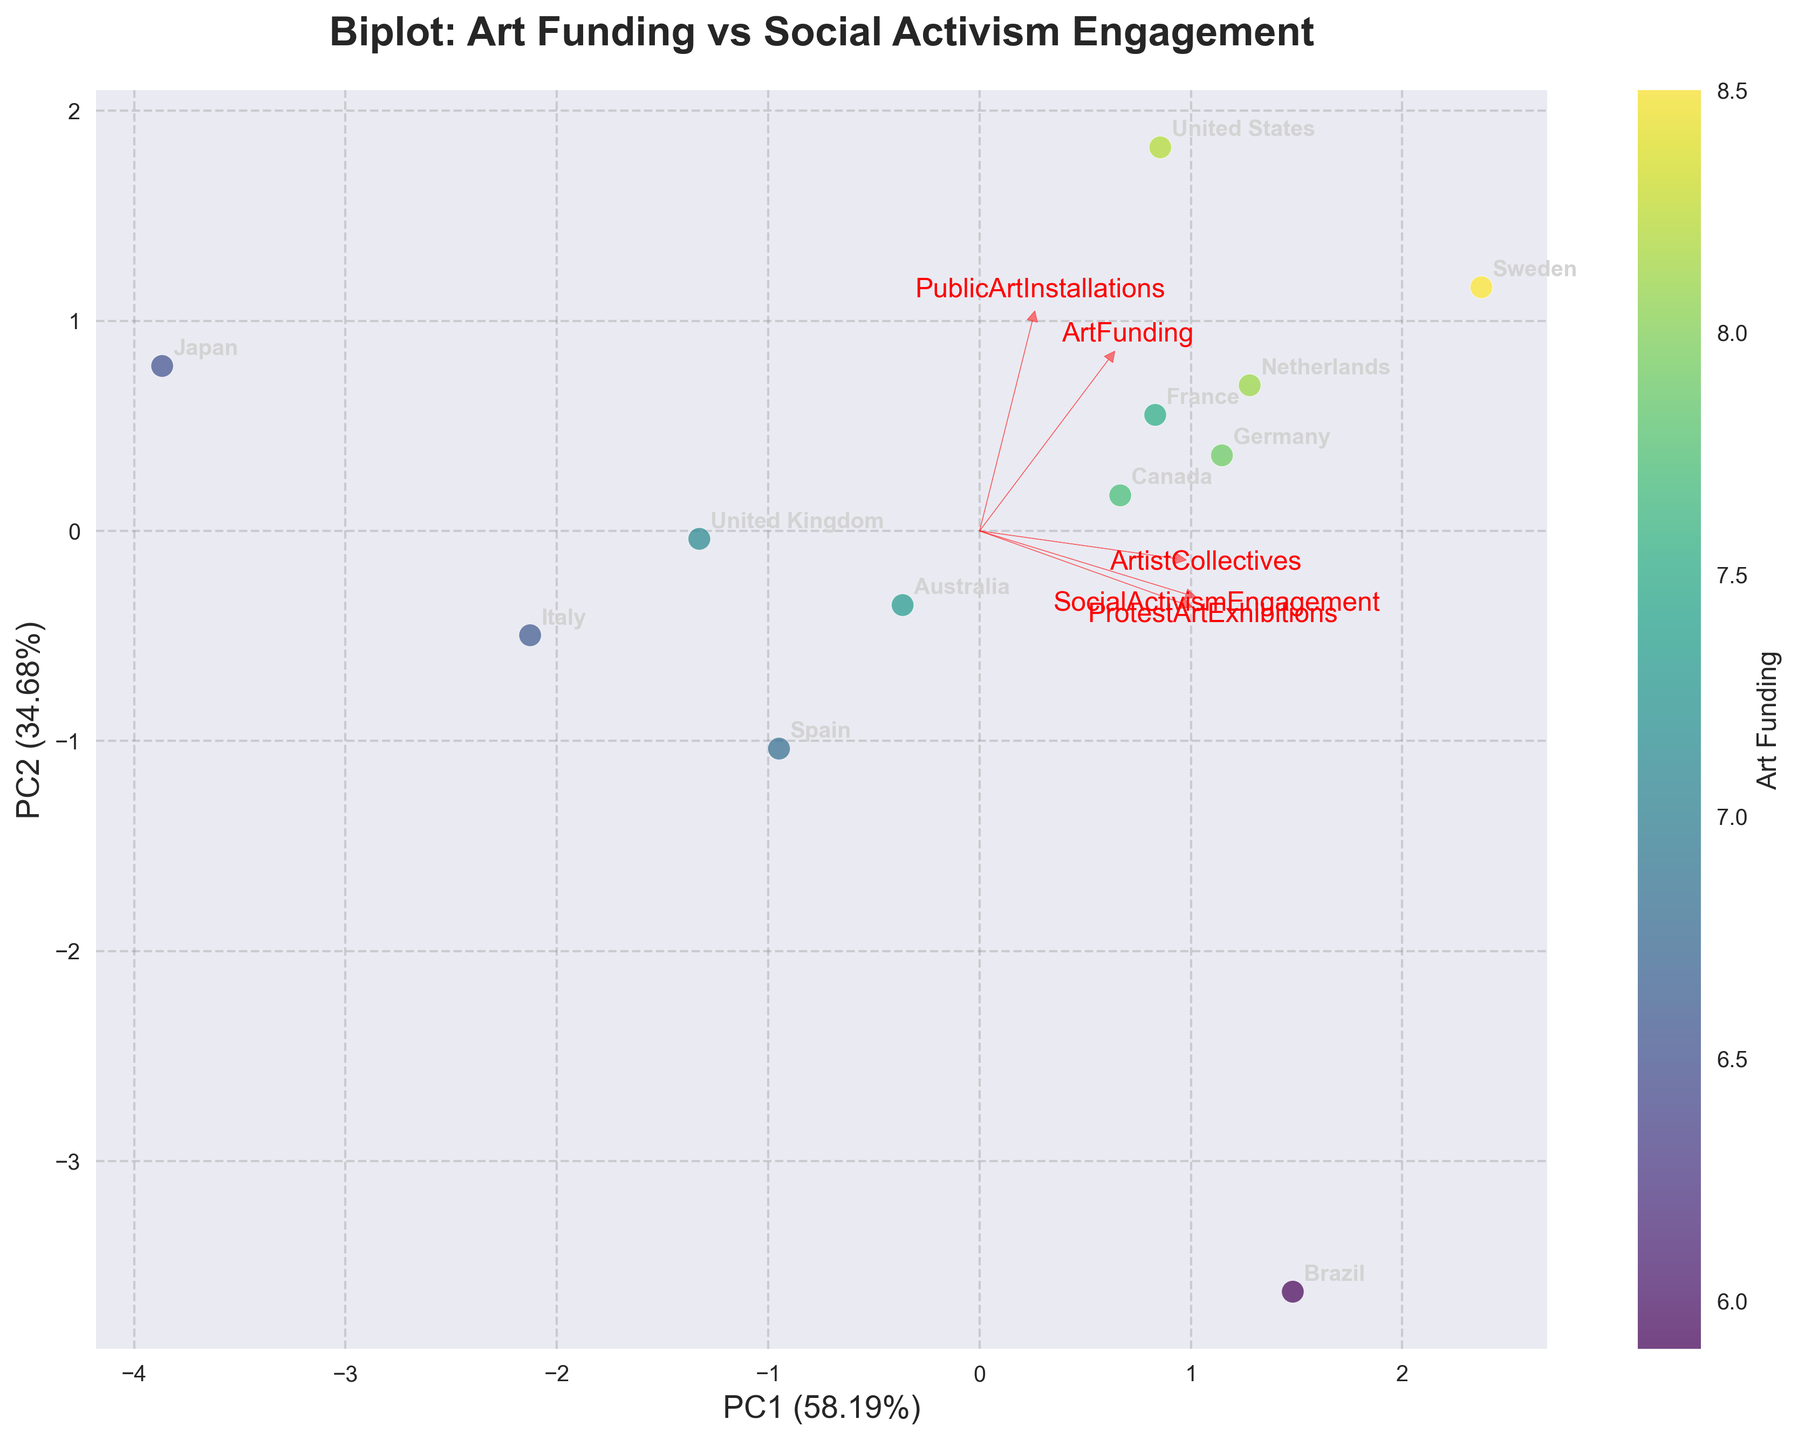What is the title of the figure? The title of the figure is prominently displayed at the top and reads "Biplot: Art Funding vs Social Activism Engagement".
Answer: Biplot: Art Funding vs Social Activism Engagement How many countries are represented in the plot? There are 12 countries labeled in the plot, as the data includes 12 unique country names annotated in the visualization.
Answer: 12 Which country has the highest social activism engagement? The highest social activism engagement is represented by the y-axis component of the PCA biplot, and by examining the plot, Brazil appears to be positioned highest along this axis.
Answer: Brazil Which features have the longest vectors and what does that signify? The features with the longest vectors are 'ArtistCollectives' and 'ProtestArtExhibitions', which point in directions on the plot. Longer vectors indicate a stronger contribution of these variables to the principal components.
Answer: ArtistCollectives, ProtestArtExhibitions Which country is most closely associated with high art funding and high public art installations? From the plot, countries represented by data points in the direction of 'ArtFunding' and 'PublicArtInstallations' vectors are closely associated with these features. The United States, placed favorably in this direction, aligns closely.
Answer: United States How do the public art installations relate to protest art exhibitions based on the figure? The vectors for 'PublicArtInstallations' and 'ProtestArtExhibitions' are pointing in somewhat similar directions but not perfectly aligned, indicating there is a positive but not perfect correlation between these two features.
Answer: Positive correlation Are there any countries where social activism engagement is high but art funding is low? Examining the position of countries in the plot, Brazil stands out with high social activism engagement (upper part of the plot) but moderate to low art funding (center-left), compared to others.
Answer: Brazil Which two features seem to be the most positively correlated based on their vector alignment? The vectors for 'ArtFunding' and 'ArtistCollectives' are nearly parallel and heading in the same direction, which indicates a strong positive correlation between these features.
Answer: ArtFunding, ArtistCollectives Which feature seems to have the least impact on the second principal component (PC2)? The length and orientation of vectors help in identifying feature impacts. 'PublicArtInstallations' has the shortest projection on PC2 suggesting the least influence on this component.
Answer: PublicArtInstallations What is the proportion of variance explained by the first principal component (PC1)? The explained variance by PC1 is provided in the label of the x-axis. It indicates that PC1 captures a dominant portion of the data's variability, which is 41%.
Answer: 41% 